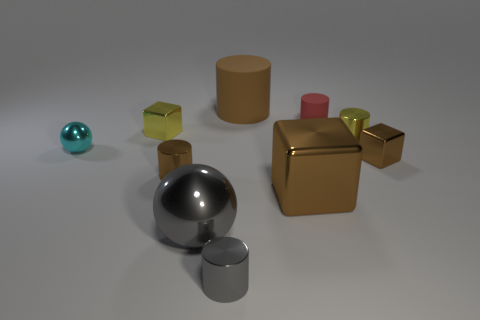What size is the brown cylinder to the left of the big brown object that is behind the tiny matte cylinder?
Your answer should be compact. Small. Is the material of the sphere that is on the right side of the cyan thing the same as the big cylinder?
Your answer should be compact. No. What is the shape of the big gray object that is right of the yellow block?
Give a very brief answer. Sphere. What number of gray spheres have the same size as the brown matte cylinder?
Make the answer very short. 1. What size is the yellow cylinder?
Ensure brevity in your answer.  Small. How many yellow metal cylinders are behind the gray metal sphere?
Your response must be concise. 1. There is a big brown thing that is the same material as the small sphere; what shape is it?
Your answer should be compact. Cube. Is the number of matte cylinders on the right side of the small red thing less than the number of metal cylinders that are on the right side of the big brown metal cube?
Provide a short and direct response. Yes. Are there more large cyan cylinders than metallic things?
Keep it short and to the point. No. What is the material of the cyan thing?
Provide a succinct answer. Metal. 